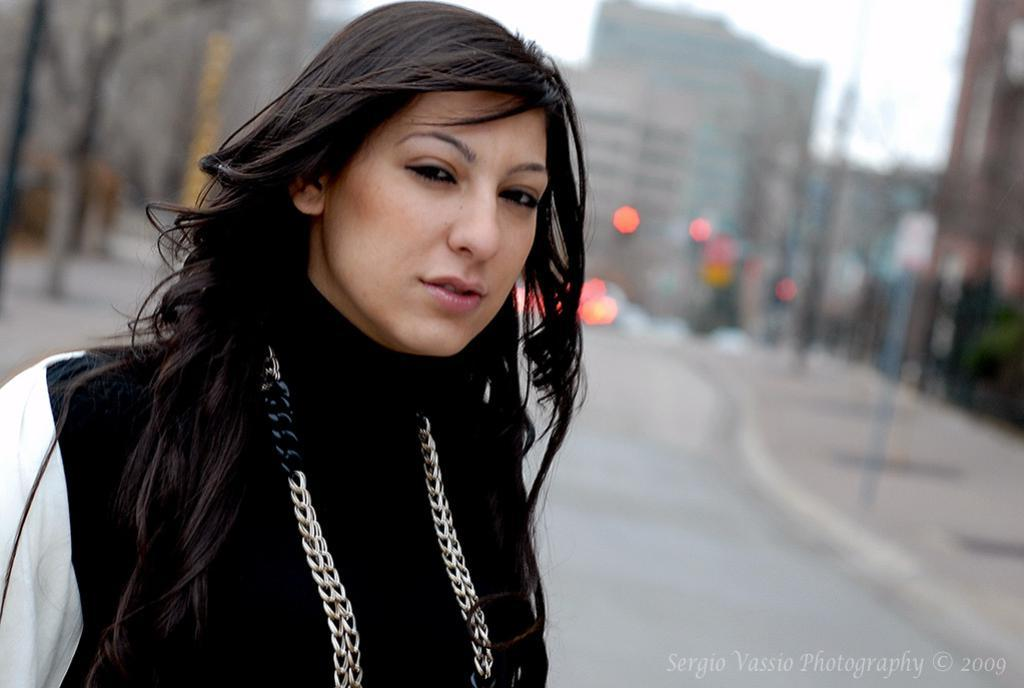Who is the main subject in the image? There is a woman in the image. How is the woman being emphasized in the image? The woman is highlighted. What type of accessory is the woman wearing? The woman is wearing a chain. What color is the woman's t-shirt? The woman is wearing a black t-shirt. What can be seen in the background of the image? There are buildings in the background of the image. What type of square object is being used as a pillow by the woman in the image? There is no square object or pillow present in the image; the woman is not lying down or resting. What type of pipe can be seen connecting the buildings in the background of the image? There are no pipes visible connecting the buildings in the background of the image. 